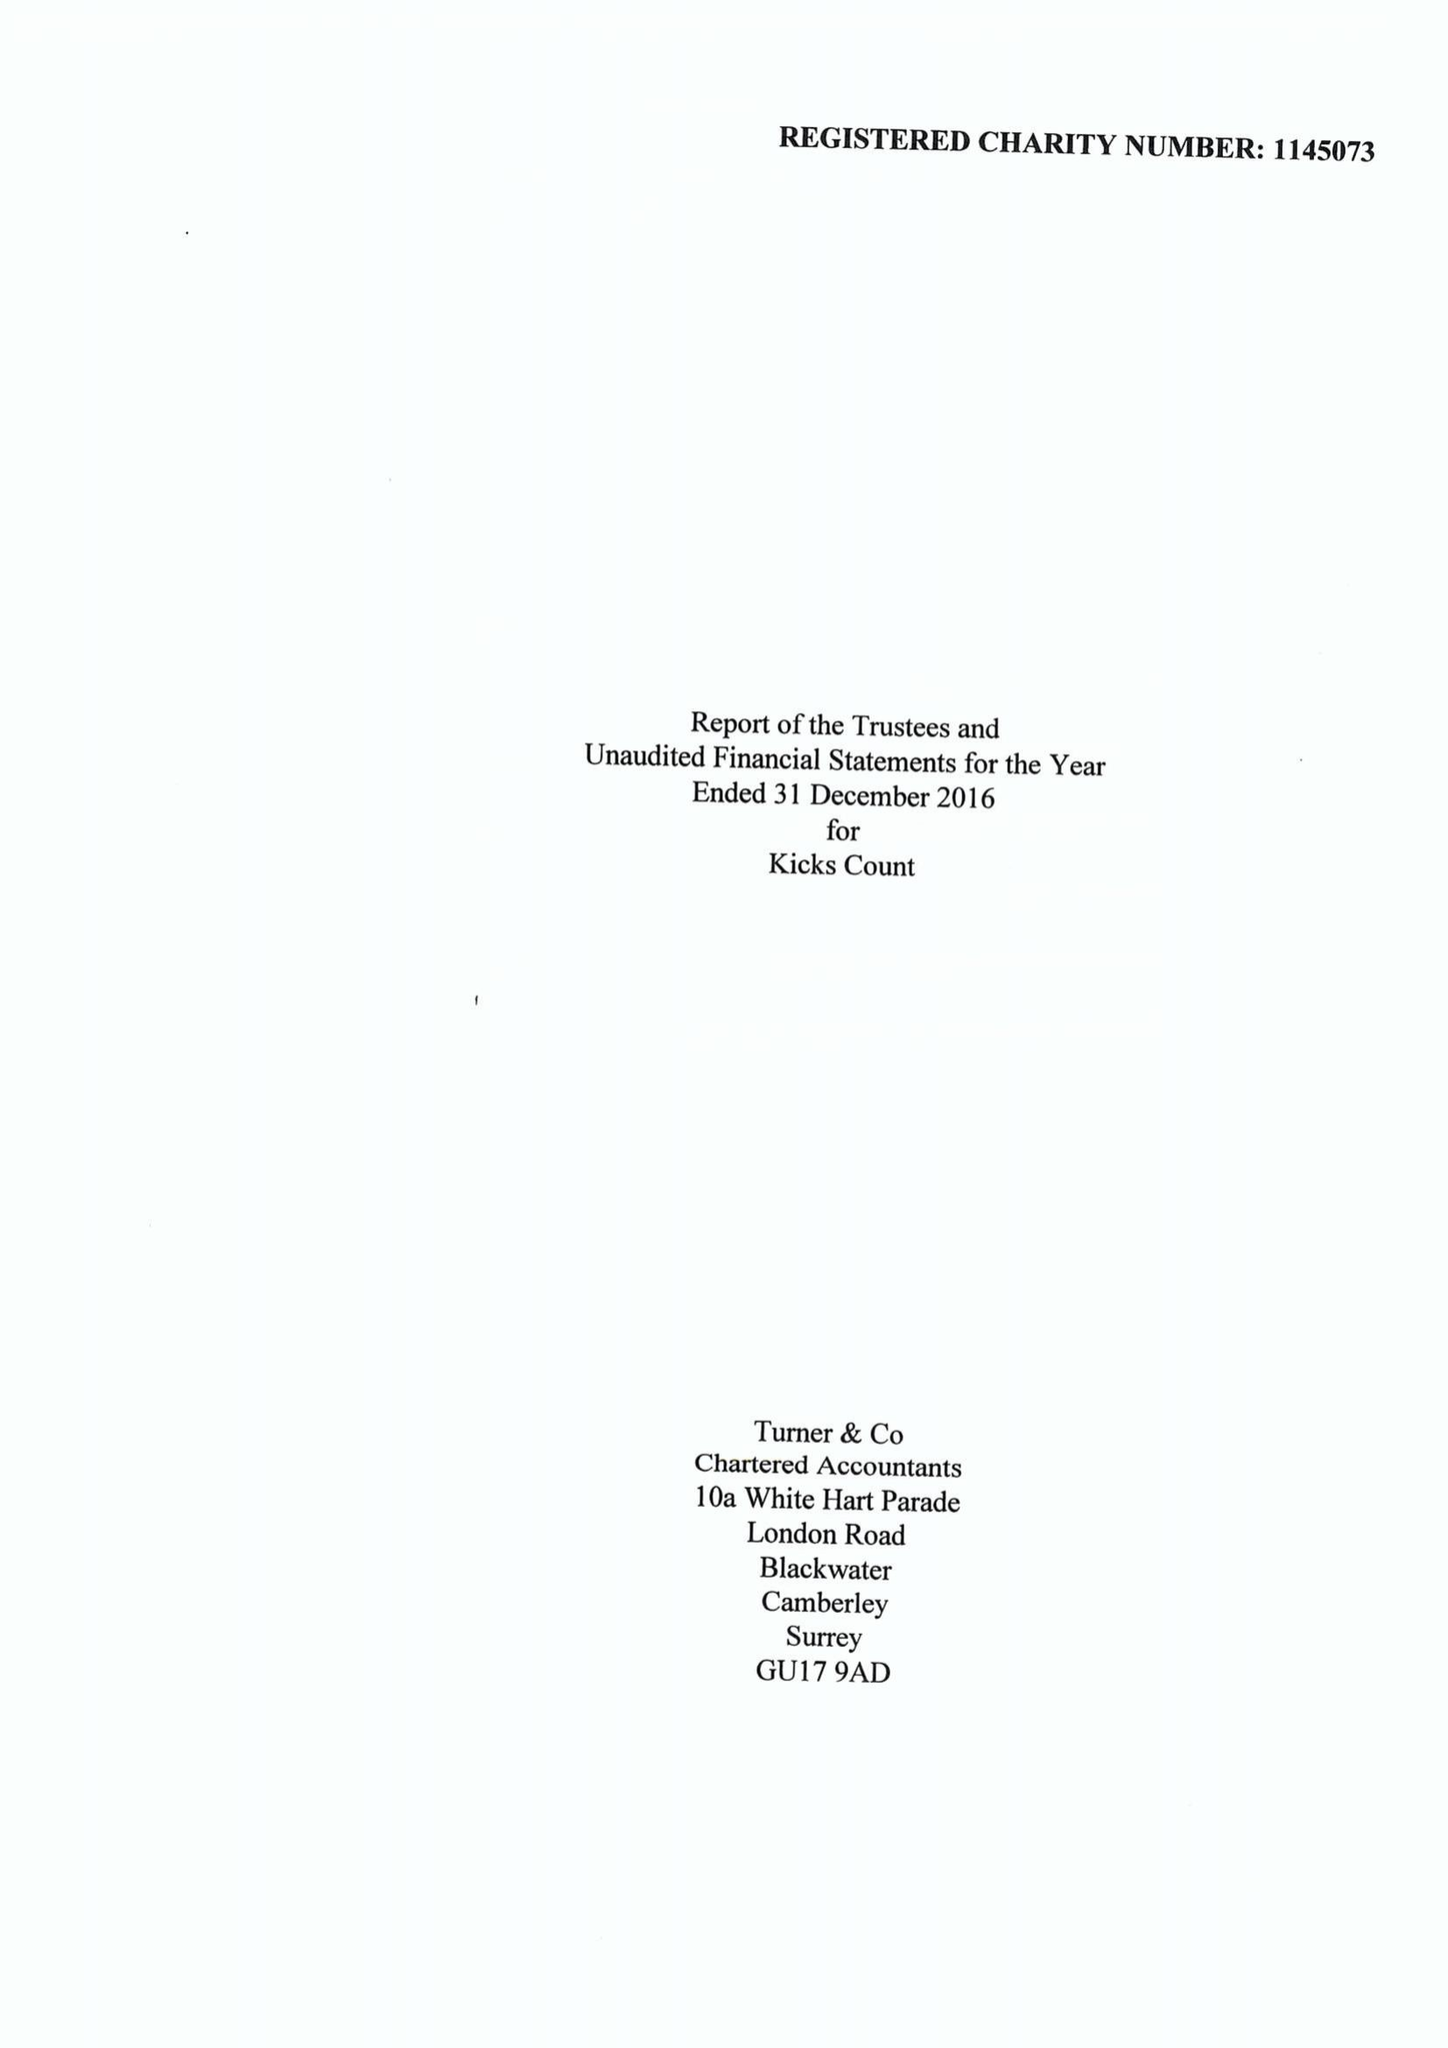What is the value for the charity_number?
Answer the question using a single word or phrase. 1145073 